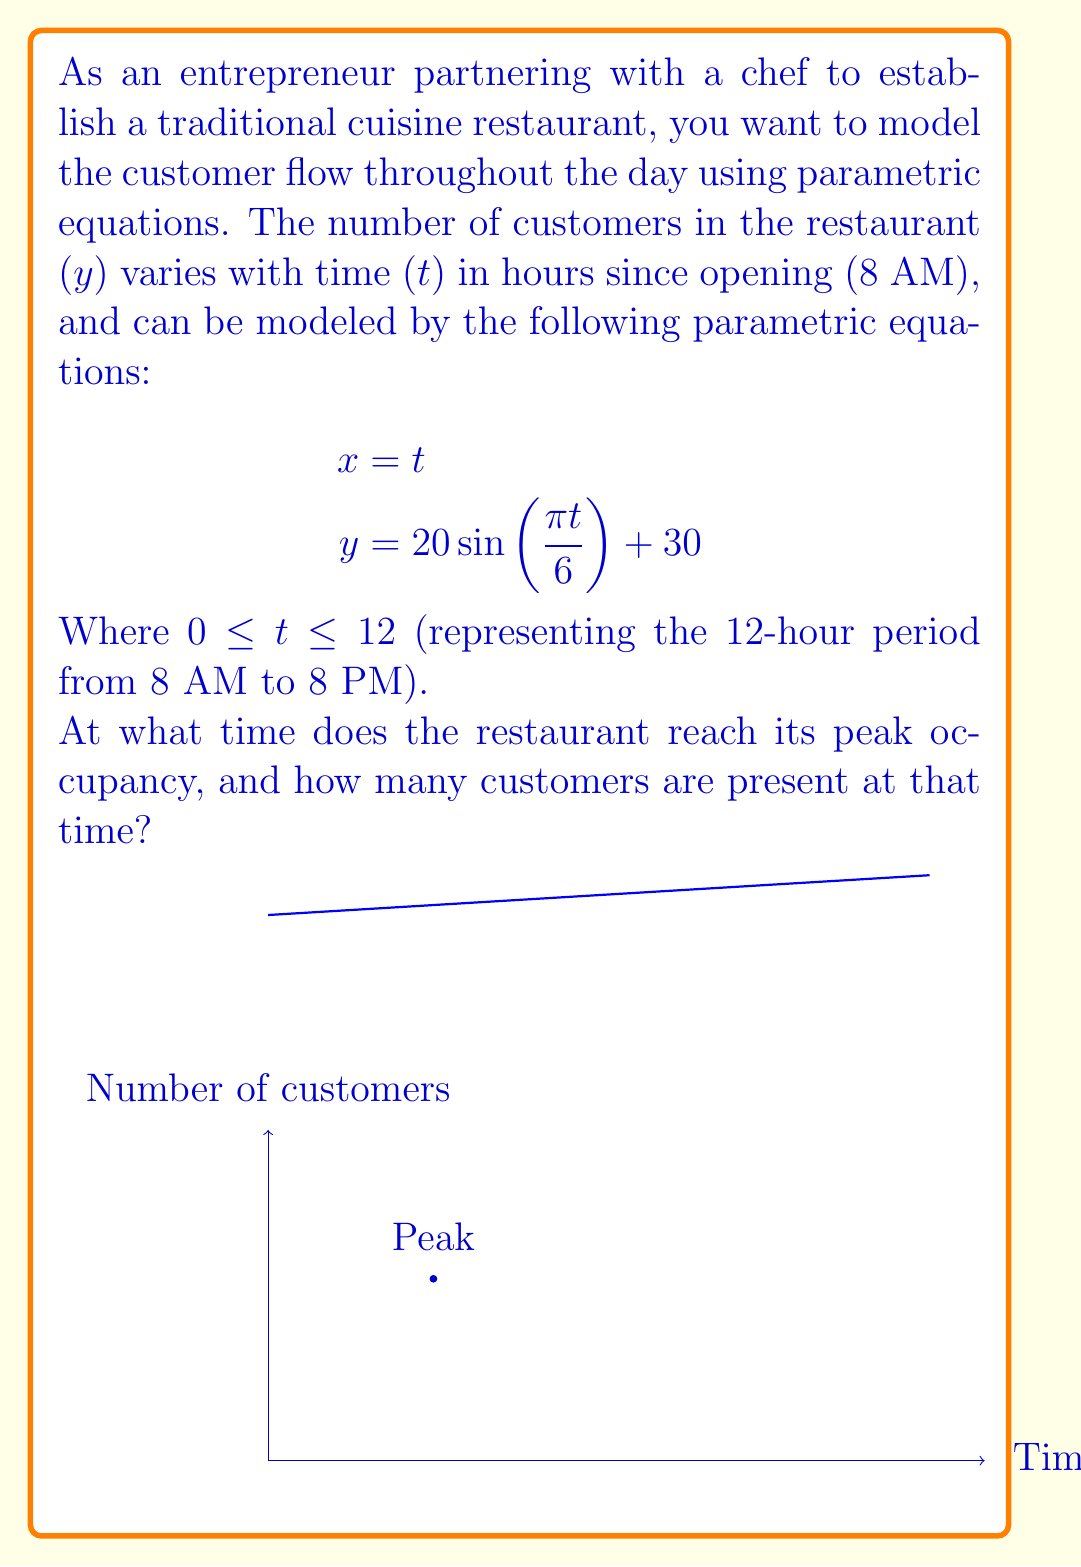Help me with this question. To solve this problem, we need to follow these steps:

1) The peak occupancy occurs when $y$ is at its maximum value. In a sine function, this happens when the argument of sine is $\frac{\pi}{2}$.

2) Let's set up the equation:

   $$\frac{\pi t}{6} = \frac{\pi}{2}$$

3) Solve for $t$:
   
   $$t = \frac{6}{2} = 3$$

4) This means the peak occurs 3 hours after opening, which is at 11 AM.

5) To find the number of customers at this time, we substitute $t = 3$ into the equation for $y$:

   $$y = 20 \sin(\frac{\pi \cdot 3}{6}) + 30$$
   $$= 20 \sin(\frac{\pi}{2}) + 30$$
   $$= 20 \cdot 1 + 30 = 50$$

Therefore, the restaurant reaches its peak occupancy at 11 AM (3 hours after opening), with 50 customers present.
Answer: 11 AM, 50 customers 